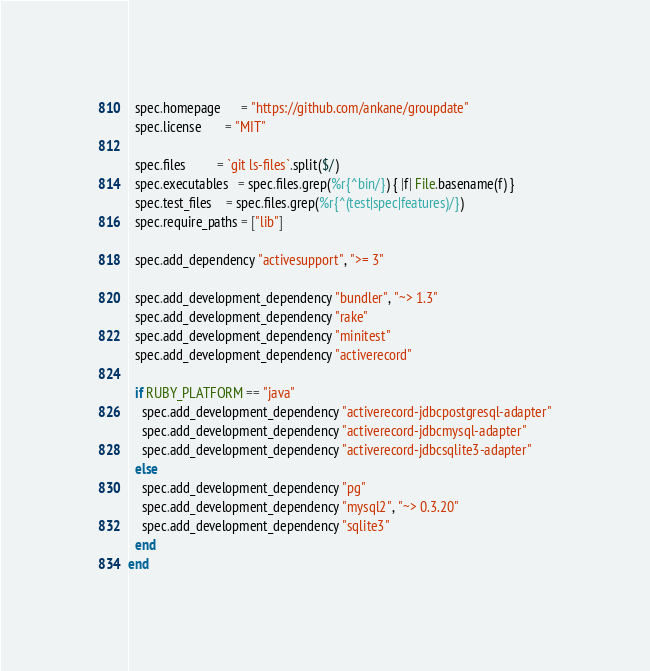<code> <loc_0><loc_0><loc_500><loc_500><_Ruby_>  spec.homepage      = "https://github.com/ankane/groupdate"
  spec.license       = "MIT"

  spec.files         = `git ls-files`.split($/)
  spec.executables   = spec.files.grep(%r{^bin/}) { |f| File.basename(f) }
  spec.test_files    = spec.files.grep(%r{^(test|spec|features)/})
  spec.require_paths = ["lib"]

  spec.add_dependency "activesupport", ">= 3"

  spec.add_development_dependency "bundler", "~> 1.3"
  spec.add_development_dependency "rake"
  spec.add_development_dependency "minitest"
  spec.add_development_dependency "activerecord"

  if RUBY_PLATFORM == "java"
    spec.add_development_dependency "activerecord-jdbcpostgresql-adapter"
    spec.add_development_dependency "activerecord-jdbcmysql-adapter"
    spec.add_development_dependency "activerecord-jdbcsqlite3-adapter"
  else
    spec.add_development_dependency "pg"
    spec.add_development_dependency "mysql2", "~> 0.3.20"
    spec.add_development_dependency "sqlite3"
  end
end
</code> 